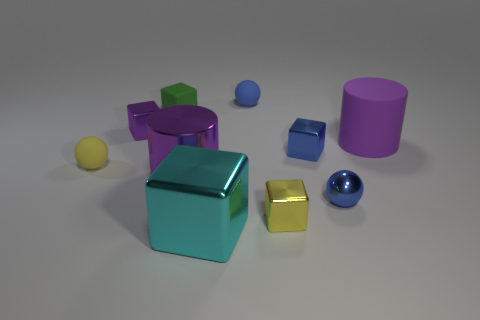Subtract all blue blocks. How many blocks are left? 4 Subtract all yellow blocks. How many blocks are left? 4 Subtract 2 cubes. How many cubes are left? 3 Subtract all brown blocks. Subtract all cyan cylinders. How many blocks are left? 5 Subtract all balls. How many objects are left? 7 Subtract all small purple matte cubes. Subtract all tiny blue blocks. How many objects are left? 9 Add 6 small matte spheres. How many small matte spheres are left? 8 Add 8 gray cylinders. How many gray cylinders exist? 8 Subtract 0 green cylinders. How many objects are left? 10 